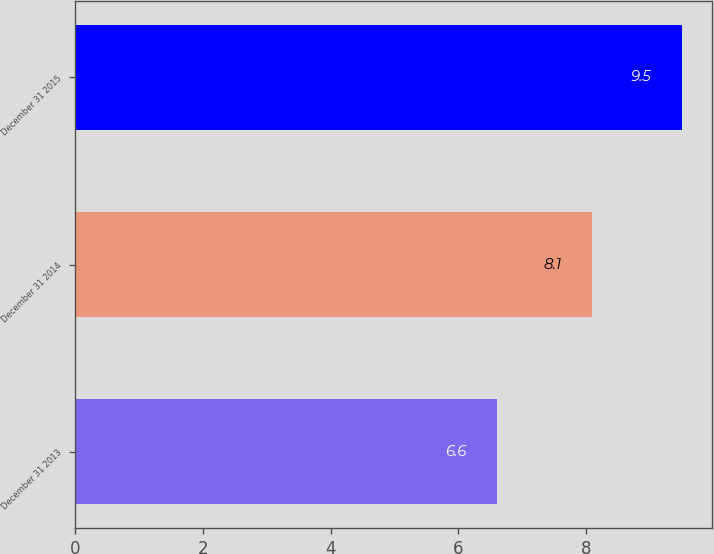Convert chart. <chart><loc_0><loc_0><loc_500><loc_500><bar_chart><fcel>December 31 2013<fcel>December 31 2014<fcel>December 31 2015<nl><fcel>6.6<fcel>8.1<fcel>9.5<nl></chart> 